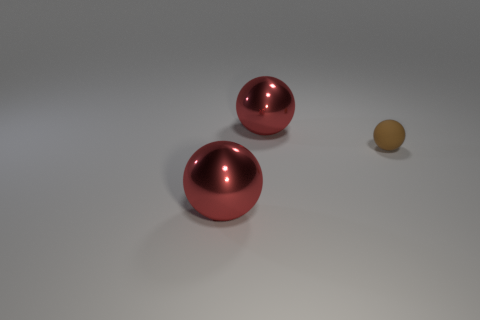Add 3 matte objects. How many objects exist? 6 Subtract all tiny gray rubber cylinders. Subtract all brown spheres. How many objects are left? 2 Add 1 small brown things. How many small brown things are left? 2 Add 2 matte things. How many matte things exist? 3 Subtract 0 yellow balls. How many objects are left? 3 